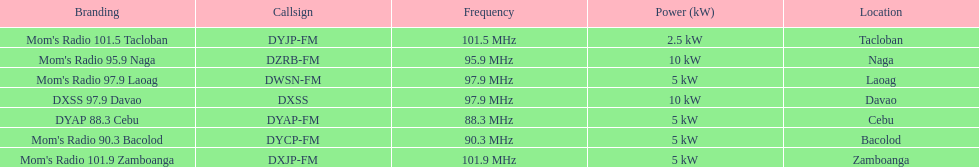Help me parse the entirety of this table. {'header': ['Branding', 'Callsign', 'Frequency', 'Power (kW)', 'Location'], 'rows': [["Mom's Radio 101.5 Tacloban", 'DYJP-FM', '101.5\xa0MHz', '2.5\xa0kW', 'Tacloban'], ["Mom's Radio 95.9 Naga", 'DZRB-FM', '95.9\xa0MHz', '10\xa0kW', 'Naga'], ["Mom's Radio 97.9 Laoag", 'DWSN-FM', '97.9\xa0MHz', '5\xa0kW', 'Laoag'], ['DXSS 97.9 Davao', 'DXSS', '97.9\xa0MHz', '10\xa0kW', 'Davao'], ['DYAP 88.3 Cebu', 'DYAP-FM', '88.3\xa0MHz', '5\xa0kW', 'Cebu'], ["Mom's Radio 90.3 Bacolod", 'DYCP-FM', '90.3\xa0MHz', '5\xa0kW', 'Bacolod'], ["Mom's Radio 101.9 Zamboanga", 'DXJP-FM', '101.9\xa0MHz', '5\xa0kW', 'Zamboanga']]} Which of these stations broadcasts with the least power? Mom's Radio 101.5 Tacloban. 